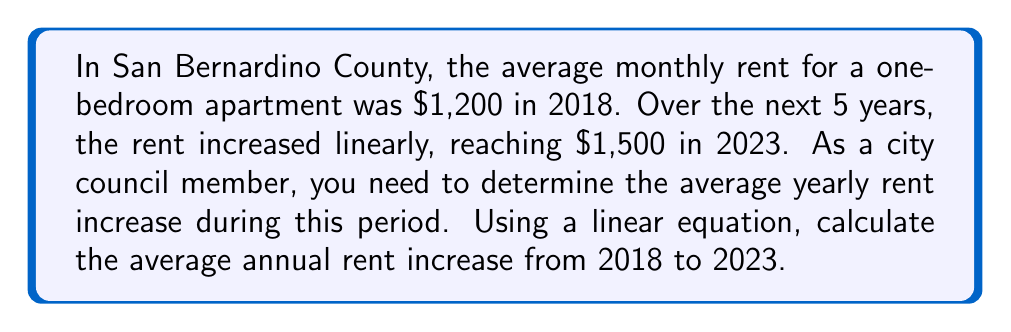Can you solve this math problem? Let's approach this step-by-step:

1) We can represent the linear increase in rent using the equation:
   $y = mx + b$
   where $y$ is the rent, $m$ is the yearly increase, $x$ is the number of years since 2018, and $b$ is the initial rent in 2018.

2) We know two points:
   (0, 1200) for 2018
   (5, 1500) for 2023

3) We can find $m$ (the yearly increase) using the slope formula:
   $$m = \frac{y_2 - y_1}{x_2 - x_1} = \frac{1500 - 1200}{5 - 0} = \frac{300}{5} = 60$$

4) This means the rent increased by $60 per year on average.

5) We can verify this by plugging it back into our linear equation:
   $y = 60x + 1200$

   For 2023 (x = 5):
   $y = 60(5) + 1200 = 300 + 1200 = 1500$

   This matches our given information.
Answer: $60 per year 